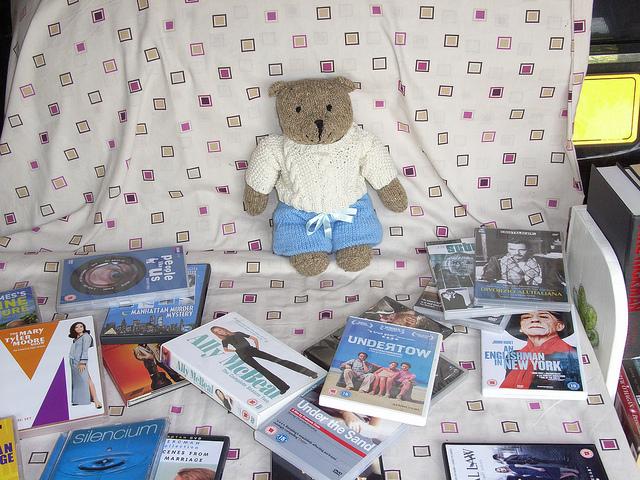How many books are shown?
Write a very short answer. 0. Which stuffed animal is shown?
Be succinct. Bear. Which DVD features an attorney?
Write a very short answer. Ally mcbeal. 